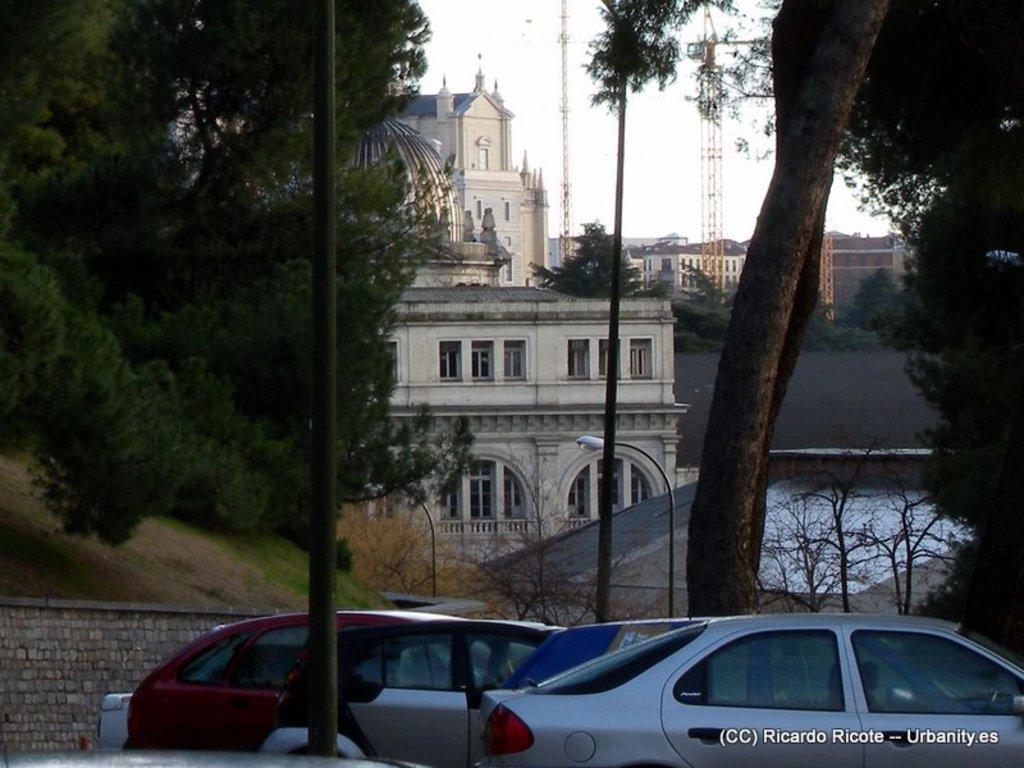In one or two sentences, can you explain what this image depicts? In this image there are trees and a wall on the left corner. There are vehicles and a metal pole in the foreground. There are trees on the right corner. There are buildings and trees in the background. And there is sky at the top. 